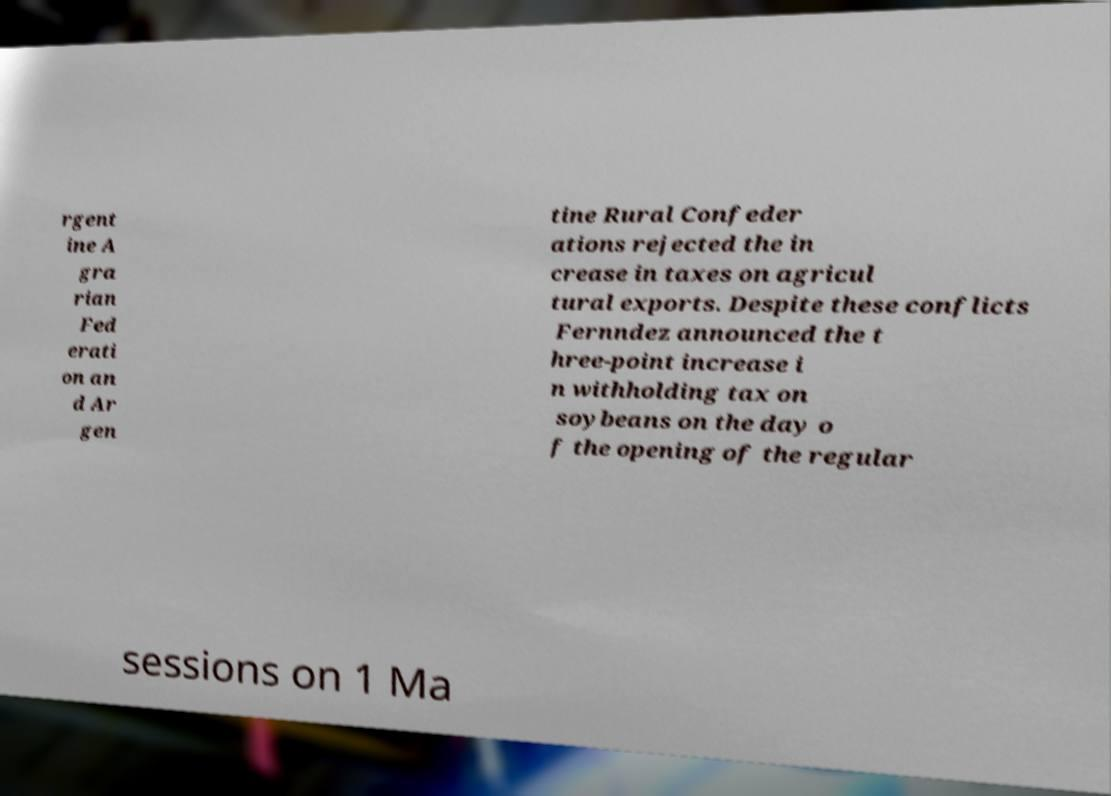What messages or text are displayed in this image? I need them in a readable, typed format. rgent ine A gra rian Fed erati on an d Ar gen tine Rural Confeder ations rejected the in crease in taxes on agricul tural exports. Despite these conflicts Fernndez announced the t hree-point increase i n withholding tax on soybeans on the day o f the opening of the regular sessions on 1 Ma 